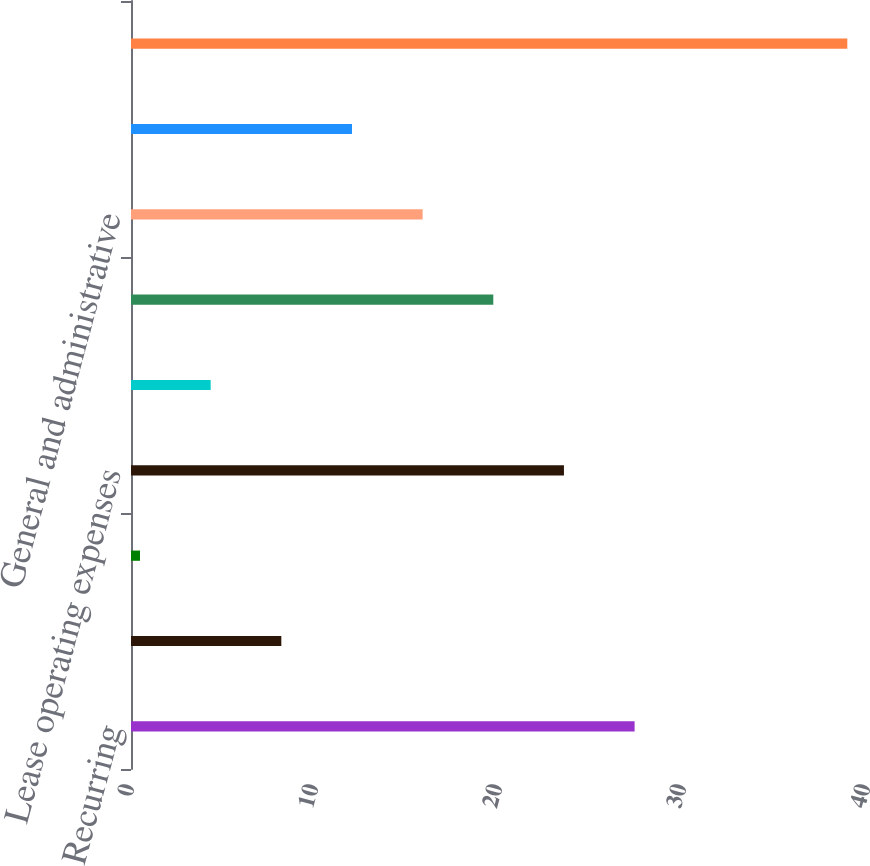<chart> <loc_0><loc_0><loc_500><loc_500><bar_chart><fcel>Recurring<fcel>Other assets<fcel>Asset retirement obligation<fcel>Lease operating expenses<fcel>Gathering and transportation<fcel>Taxes other than income<fcel>General and administrative<fcel>Financing costs net<fcel>Total<nl><fcel>27.37<fcel>8.17<fcel>0.49<fcel>23.53<fcel>4.33<fcel>19.69<fcel>15.85<fcel>12.01<fcel>38.93<nl></chart> 